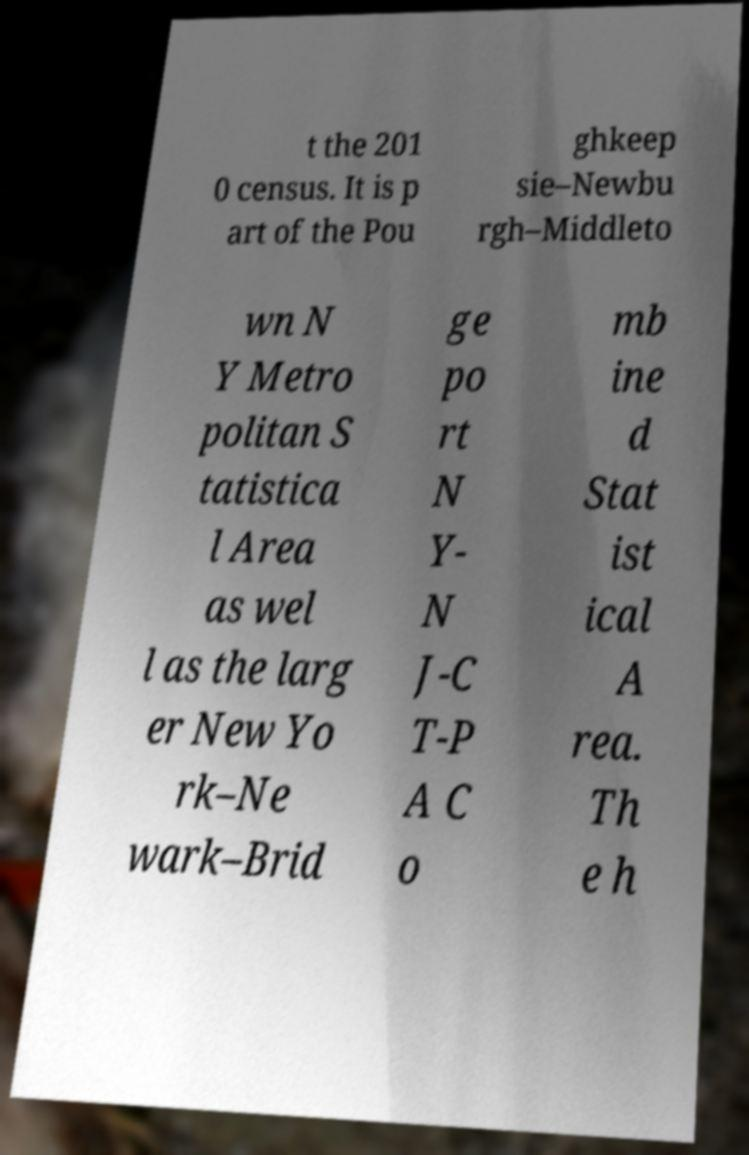Can you accurately transcribe the text from the provided image for me? t the 201 0 census. It is p art of the Pou ghkeep sie–Newbu rgh–Middleto wn N Y Metro politan S tatistica l Area as wel l as the larg er New Yo rk–Ne wark–Brid ge po rt N Y- N J-C T-P A C o mb ine d Stat ist ical A rea. Th e h 